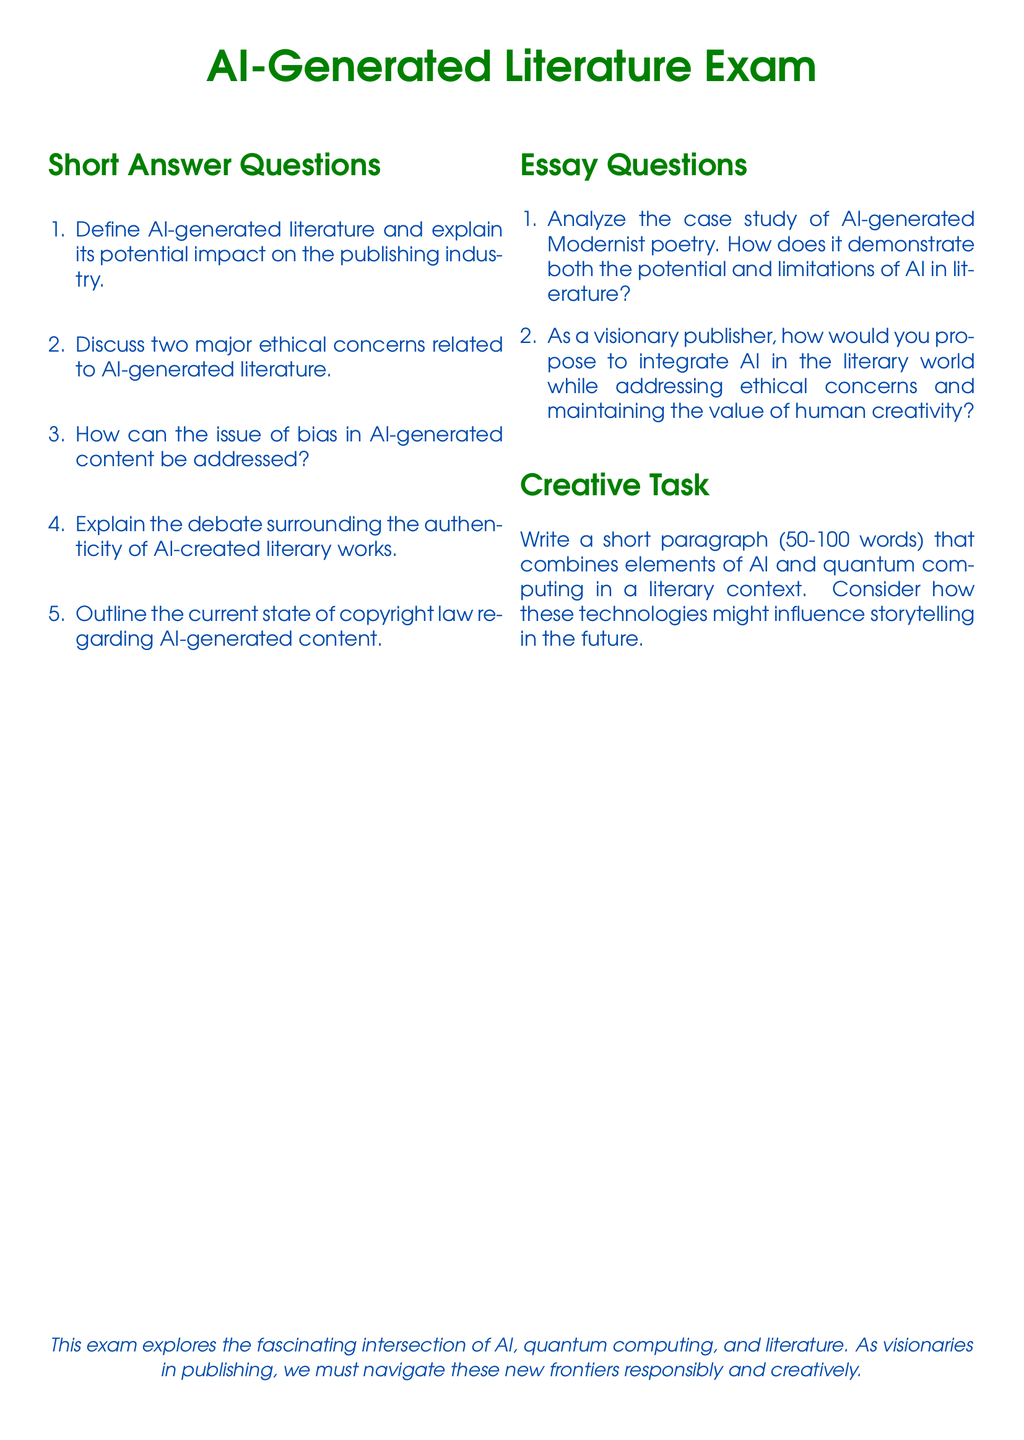What is the title of the exam? The title of the exam is presented at the top of the document in a prominent font style.
Answer: AI-Generated Literature Exam How many types of questions are included in the exam? The exam includes three distinct sections: short answer questions, essay questions, and a creative task.
Answer: Three What color is used for the exam title? The title of the exam is rendered in a specific color to stand out.
Answer: AIGreen What does the creative task require the respondent to do? The creative task asks the respondent to write a short paragraph integrating specific technologies in a literary context.
Answer: Write a short paragraph Name one ethical concern related to AI-generated literature mentioned in the short answer questions. The question specifically asks for ethical concerns associated with AI-generated literature.
Answer: Two major ethical concerns What is the format of the essay questions in the document? The essay questions are presented in a structured list format, requiring in-depth responses to specific prompts.
Answer: Structured list format How many words should the creative task paragraph contain? The creative task specifies a word limit for the written paragraph.
Answer: 50-100 words What technological elements are mentioned in the creative task? The creative task requires consideration of specific modern technologies and their literary influence.
Answer: AI and quantum computing What is the primary theme of the exam? The exam explores a significant intersection that relates to the implications of contemporary technologies in a specific field.
Answer: Intersection of AI, quantum computing, and literature 